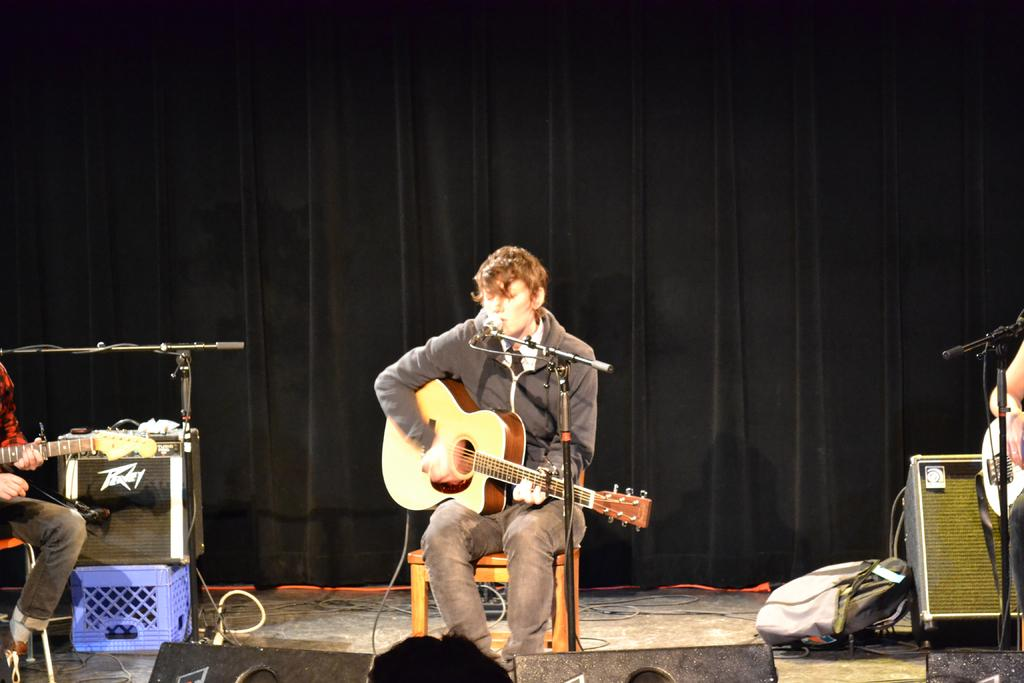What are the people in the image doing? The people in the image are playing guitars. What equipment is visible in the image that might be used for amplifying sound? There is a microphone in front of the people and a speaker in the background of the image. What can be seen in the background of the image? There are bags or baggage, curtains, and a speaker in the background of the image. How comfortable is the trail in the image? There is no trail present in the image; it features a group of people playing guitars with related equipment. 